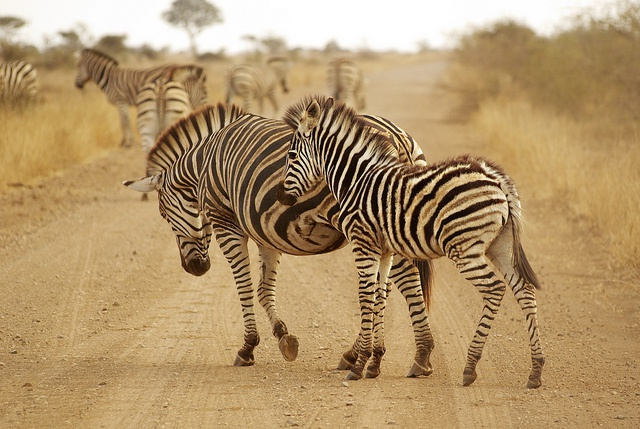Describe the objects in this image and their specific colors. I can see zebra in white, black, tan, maroon, and gray tones, zebra in white, black, tan, and maroon tones, zebra in white, tan, gray, and brown tones, zebra in white, gray, tan, brown, and olive tones, and zebra in white, tan, and olive tones in this image. 